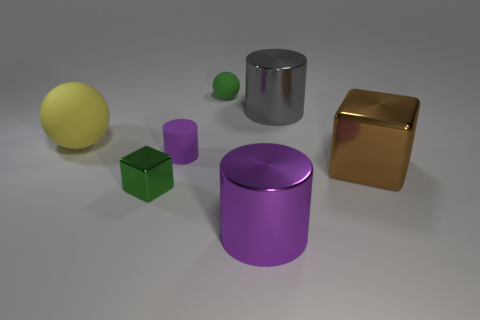How many big objects are rubber cylinders or brown rubber cylinders?
Offer a terse response. 0. What is the material of the other tiny object that is the same shape as the brown object?
Offer a very short reply. Metal. Is there any other thing that is the same material as the big purple cylinder?
Your answer should be very brief. Yes. What is the color of the large rubber ball?
Offer a very short reply. Yellow. Do the small ball and the small cylinder have the same color?
Your response must be concise. No. What number of big brown shiny blocks are to the right of the purple cylinder that is in front of the tiny rubber cylinder?
Make the answer very short. 1. There is a cylinder that is both in front of the gray metallic cylinder and behind the green shiny thing; what size is it?
Keep it short and to the point. Small. What material is the big cylinder behind the large yellow matte object?
Make the answer very short. Metal. Is there a yellow object that has the same shape as the large gray object?
Your response must be concise. No. What number of other small green metal objects are the same shape as the small green shiny thing?
Provide a short and direct response. 0. 